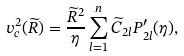<formula> <loc_0><loc_0><loc_500><loc_500>v _ { c } ^ { 2 } ( { \widetilde { R } } ) = \frac { { \widetilde { R } } ^ { 2 } } { \eta } \sum _ { l = 1 } ^ { n } { \widetilde { C } } _ { 2 l } P ^ { \prime } _ { 2 l } ( \eta ) ,</formula> 